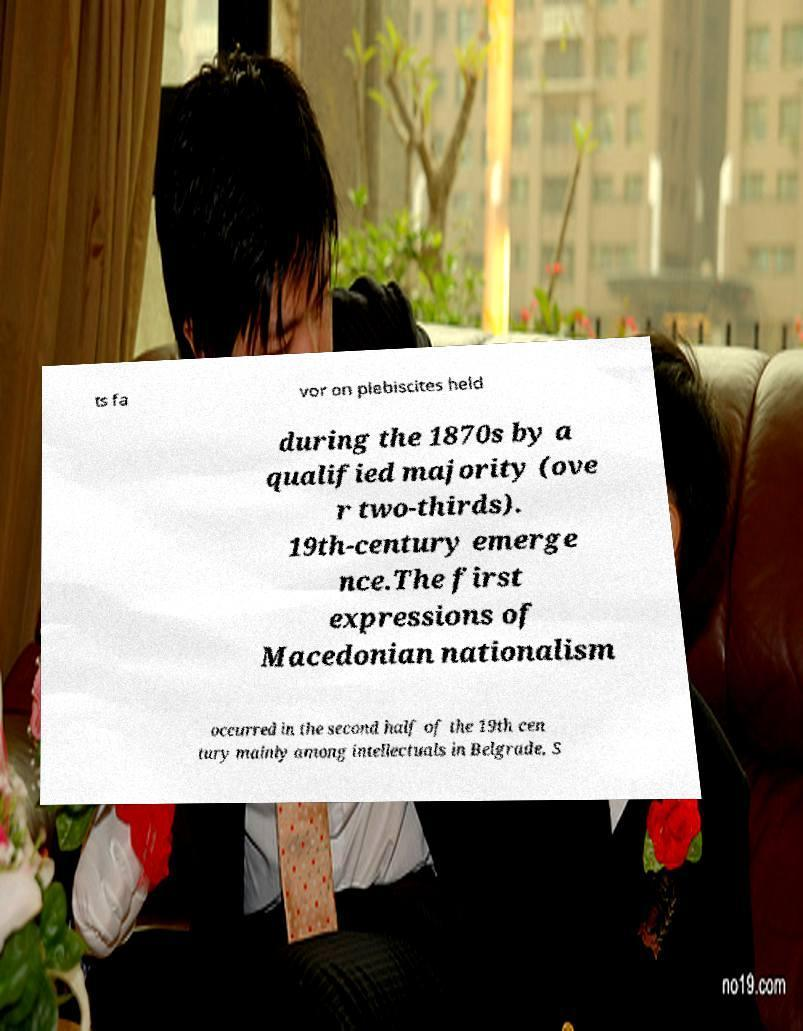There's text embedded in this image that I need extracted. Can you transcribe it verbatim? ts fa vor on plebiscites held during the 1870s by a qualified majority (ove r two-thirds). 19th-century emerge nce.The first expressions of Macedonian nationalism occurred in the second half of the 19th cen tury mainly among intellectuals in Belgrade, S 